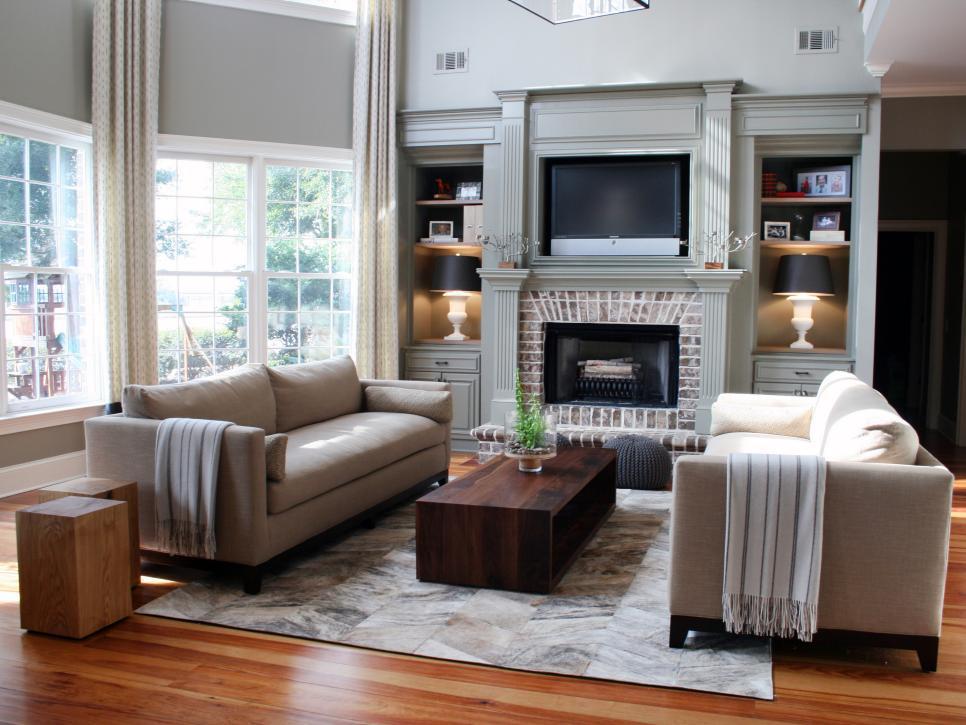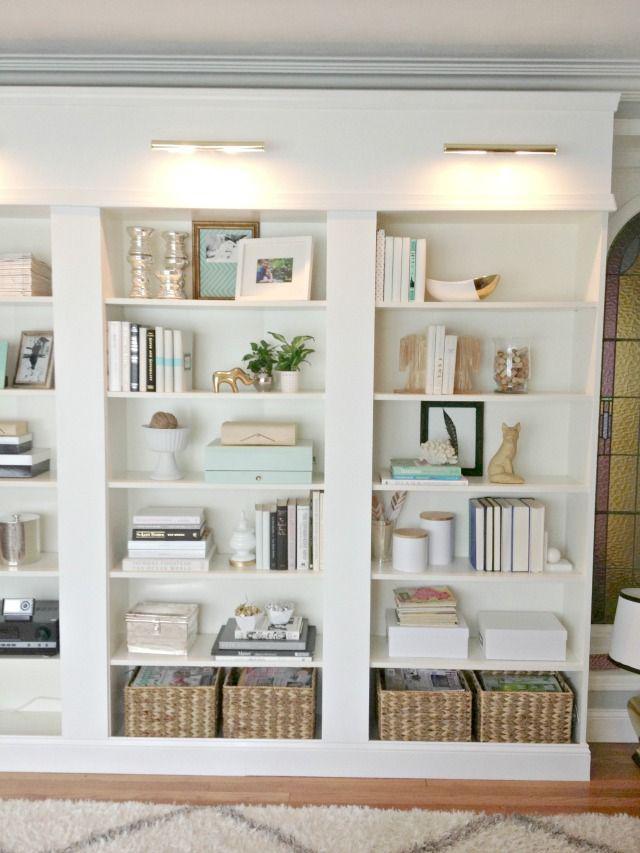The first image is the image on the left, the second image is the image on the right. Assess this claim about the two images: "In 1 of the images, the shelves have furniture in front of them.". Correct or not? Answer yes or no. Yes. The first image is the image on the left, the second image is the image on the right. Given the left and right images, does the statement "In one image, living room couches and coffee table are arranged in front of a large shelving unit." hold true? Answer yes or no. Yes. 